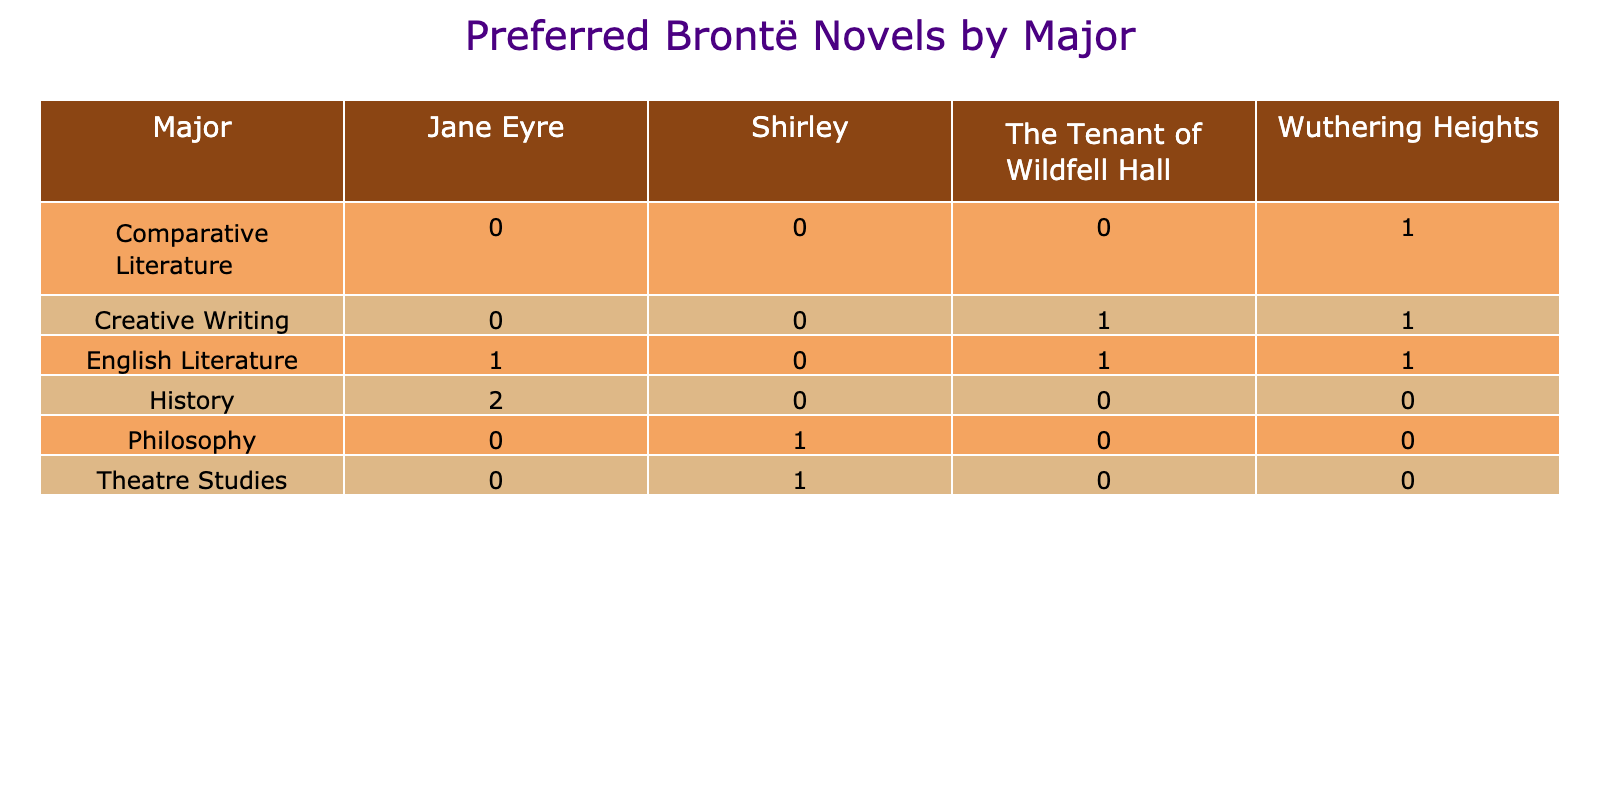What is the most preferred Brontë novel among students majoring in English Literature? Looking at the table, the students majoring in English Literature have a preference for "Jane Eyre," which appears in the relevant column with the highest count (3).
Answer: Jane Eyre How many students in the 18-24 age group prefer "Wuthering Heights"? Scanning the table for the 18-24 age group, we see that there is one student who prefers "Wuthering Heights."
Answer: 1 Do any students majoring in Philosophy prefer "The Tenant of Wildfell Hall"? Checking the Philosophy row in the table, there are no students listed who prefer "The Tenant of Wildfell Hall," indicating that this preference does not exist among that major.
Answer: No Which major has the highest overall preference for "Shirley"? The table shows that only two majors list "Shirley," Philosophy and Theatre Studies, both with one student each. Therefore, they share the highest count for this novel.
Answer: Philosophy and Theatre Studies What is the total number of students who indicated a high interest in 19th-century literature among those studying English Literature? Referring to the English Literature row, there are three students who show a high interest: the two students preferring "Jane Eyre" and one preferring "The Tenant of Wildfell Hall." Thus, we add these counts to get a total of 3.
Answer: 3 Is there any male student in the Creative Writing major who preferred “Jane Eyre”? Inspecting the Creative Writing row, there are no male students listed who prefer "Jane Eyre," so the answer is no.
Answer: No What percentage of female students in the 18-24 age group prefer "Jane Eyre"? There are three female students in the 18-24 age range, with two preferring "Jane Eyre." The calculation for percentage is (2/3) * 100, which equals approximately 66.67%.
Answer: 66.67% Which Brontë novel is most preferred by students majoring in History? Within the History major, "Jane Eyre" has the highest count, with two students indicating a preference for it, compared to only one for "Wuthering Heights."
Answer: Jane Eyre Among students aged 35-44, which novel has a single student preference, and what is their major? In the examined age group, "Wuthering Heights" is preferred by one student, and their major is Creative Writing.
Answer: Wuthering Heights, Creative Writing 